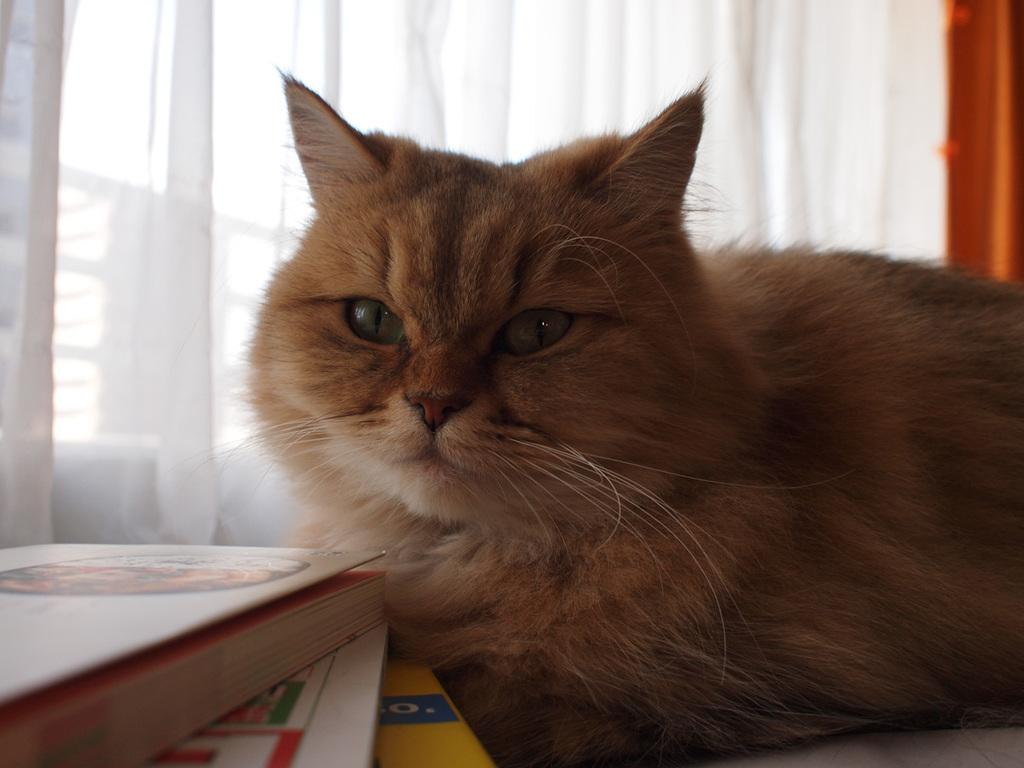What type of animal is in the image? There is a cat in the image. What objects are near the cat? There are books near the cat. What type of window treatment is visible in the image? There is a curtain visible in the image. How many windows can be seen in the image? There are windows in the image. What type of mist can be seen surrounding the cat in the image? There is no mist present in the image; it is a clear image of a cat with books, a curtain, and windows. 